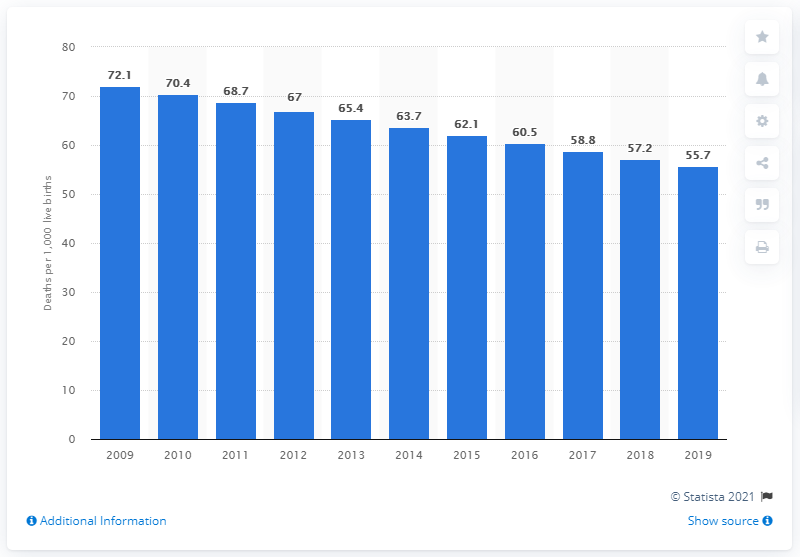Point out several critical features in this image. In 2019, the infant mortality rate in Pakistan was 55.7 deaths per 1,000 live births. 